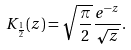Convert formula to latex. <formula><loc_0><loc_0><loc_500><loc_500>K _ { \frac { 1 } { 2 } } ( z ) = \sqrt { \frac { \pi } { 2 } } \frac { e ^ { - z } } { \sqrt { z } } .</formula> 